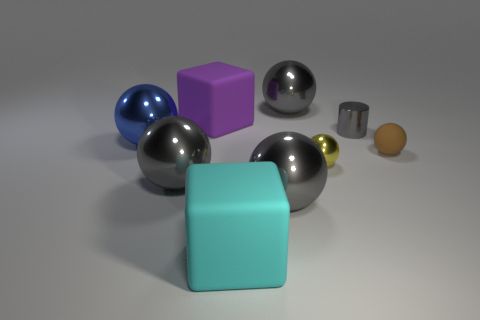How many gray balls must be subtracted to get 1 gray balls? 2 Subtract all tiny yellow spheres. How many spheres are left? 5 Add 1 tiny brown matte cylinders. How many objects exist? 10 Subtract all brown spheres. How many spheres are left? 5 Subtract all cyan blocks. How many gray balls are left? 3 Subtract 3 balls. How many balls are left? 3 Add 7 yellow metal objects. How many yellow metal objects exist? 8 Subtract 0 brown cubes. How many objects are left? 9 Subtract all cylinders. How many objects are left? 8 Subtract all yellow cylinders. Subtract all purple balls. How many cylinders are left? 1 